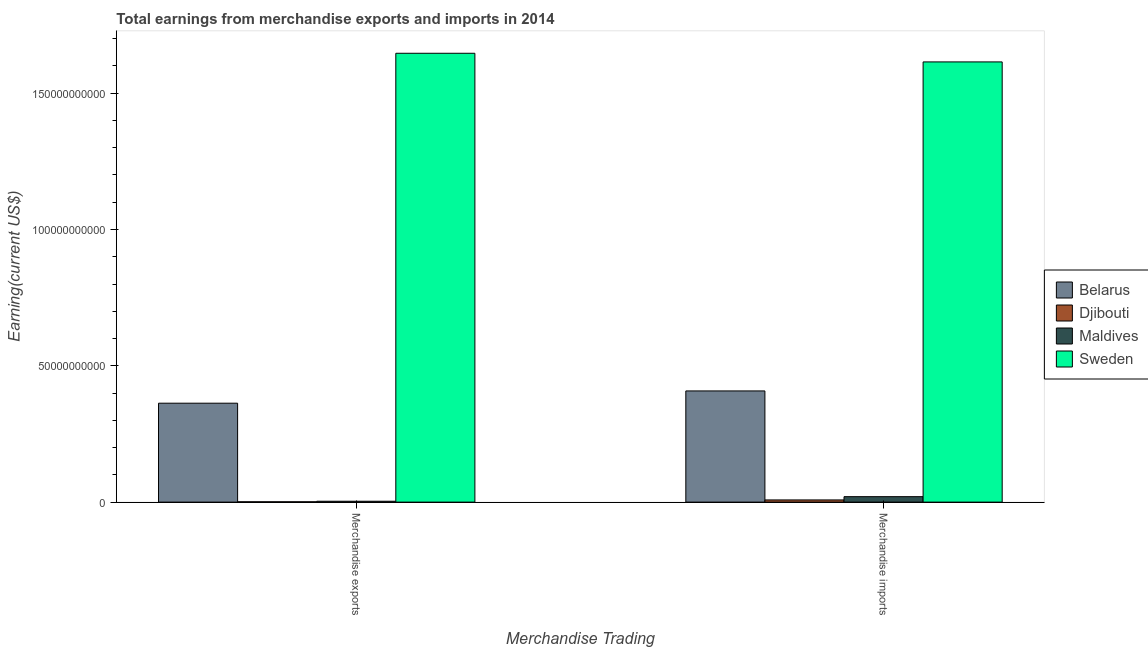Are the number of bars per tick equal to the number of legend labels?
Your response must be concise. Yes. How many bars are there on the 2nd tick from the right?
Offer a very short reply. 4. What is the earnings from merchandise exports in Maldives?
Provide a succinct answer. 3.26e+08. Across all countries, what is the maximum earnings from merchandise imports?
Give a very brief answer. 1.61e+11. Across all countries, what is the minimum earnings from merchandise exports?
Your response must be concise. 1.24e+08. In which country was the earnings from merchandise imports maximum?
Your answer should be very brief. Sweden. In which country was the earnings from merchandise imports minimum?
Ensure brevity in your answer.  Djibouti. What is the total earnings from merchandise imports in the graph?
Make the answer very short. 2.05e+11. What is the difference between the earnings from merchandise exports in Djibouti and that in Sweden?
Offer a terse response. -1.65e+11. What is the difference between the earnings from merchandise exports in Maldives and the earnings from merchandise imports in Djibouti?
Your response must be concise. -4.80e+08. What is the average earnings from merchandise imports per country?
Offer a terse response. 5.13e+1. What is the difference between the earnings from merchandise imports and earnings from merchandise exports in Belarus?
Your response must be concise. 4.50e+09. In how many countries, is the earnings from merchandise exports greater than 90000000000 US$?
Give a very brief answer. 1. What is the ratio of the earnings from merchandise exports in Djibouti to that in Belarus?
Your answer should be very brief. 0. What does the 1st bar from the left in Merchandise imports represents?
Your answer should be compact. Belarus. What does the 3rd bar from the right in Merchandise imports represents?
Your response must be concise. Djibouti. How many bars are there?
Provide a succinct answer. 8. What is the difference between two consecutive major ticks on the Y-axis?
Provide a short and direct response. 5.00e+1. Are the values on the major ticks of Y-axis written in scientific E-notation?
Ensure brevity in your answer.  No. How are the legend labels stacked?
Keep it short and to the point. Vertical. What is the title of the graph?
Ensure brevity in your answer.  Total earnings from merchandise exports and imports in 2014. Does "Angola" appear as one of the legend labels in the graph?
Your answer should be compact. No. What is the label or title of the X-axis?
Provide a short and direct response. Merchandise Trading. What is the label or title of the Y-axis?
Your response must be concise. Earning(current US$). What is the Earning(current US$) in Belarus in Merchandise exports?
Your response must be concise. 3.63e+1. What is the Earning(current US$) of Djibouti in Merchandise exports?
Your response must be concise. 1.24e+08. What is the Earning(current US$) in Maldives in Merchandise exports?
Make the answer very short. 3.26e+08. What is the Earning(current US$) in Sweden in Merchandise exports?
Offer a terse response. 1.65e+11. What is the Earning(current US$) of Belarus in Merchandise imports?
Offer a terse response. 4.08e+1. What is the Earning(current US$) in Djibouti in Merchandise imports?
Your answer should be compact. 8.06e+08. What is the Earning(current US$) of Maldives in Merchandise imports?
Your answer should be compact. 2.00e+09. What is the Earning(current US$) in Sweden in Merchandise imports?
Make the answer very short. 1.61e+11. Across all Merchandise Trading, what is the maximum Earning(current US$) in Belarus?
Give a very brief answer. 4.08e+1. Across all Merchandise Trading, what is the maximum Earning(current US$) of Djibouti?
Your response must be concise. 8.06e+08. Across all Merchandise Trading, what is the maximum Earning(current US$) in Maldives?
Your answer should be very brief. 2.00e+09. Across all Merchandise Trading, what is the maximum Earning(current US$) of Sweden?
Your response must be concise. 1.65e+11. Across all Merchandise Trading, what is the minimum Earning(current US$) of Belarus?
Make the answer very short. 3.63e+1. Across all Merchandise Trading, what is the minimum Earning(current US$) in Djibouti?
Make the answer very short. 1.24e+08. Across all Merchandise Trading, what is the minimum Earning(current US$) of Maldives?
Offer a terse response. 3.26e+08. Across all Merchandise Trading, what is the minimum Earning(current US$) of Sweden?
Your response must be concise. 1.61e+11. What is the total Earning(current US$) in Belarus in the graph?
Make the answer very short. 7.71e+1. What is the total Earning(current US$) of Djibouti in the graph?
Make the answer very short. 9.30e+08. What is the total Earning(current US$) of Maldives in the graph?
Keep it short and to the point. 2.33e+09. What is the total Earning(current US$) of Sweden in the graph?
Offer a very short reply. 3.26e+11. What is the difference between the Earning(current US$) in Belarus in Merchandise exports and that in Merchandise imports?
Offer a very short reply. -4.50e+09. What is the difference between the Earning(current US$) in Djibouti in Merchandise exports and that in Merchandise imports?
Offer a terse response. -6.82e+08. What is the difference between the Earning(current US$) of Maldives in Merchandise exports and that in Merchandise imports?
Offer a terse response. -1.68e+09. What is the difference between the Earning(current US$) of Sweden in Merchandise exports and that in Merchandise imports?
Ensure brevity in your answer.  3.17e+09. What is the difference between the Earning(current US$) in Belarus in Merchandise exports and the Earning(current US$) in Djibouti in Merchandise imports?
Keep it short and to the point. 3.55e+1. What is the difference between the Earning(current US$) of Belarus in Merchandise exports and the Earning(current US$) of Maldives in Merchandise imports?
Offer a terse response. 3.43e+1. What is the difference between the Earning(current US$) of Belarus in Merchandise exports and the Earning(current US$) of Sweden in Merchandise imports?
Offer a very short reply. -1.25e+11. What is the difference between the Earning(current US$) in Djibouti in Merchandise exports and the Earning(current US$) in Maldives in Merchandise imports?
Make the answer very short. -1.88e+09. What is the difference between the Earning(current US$) of Djibouti in Merchandise exports and the Earning(current US$) of Sweden in Merchandise imports?
Keep it short and to the point. -1.61e+11. What is the difference between the Earning(current US$) in Maldives in Merchandise exports and the Earning(current US$) in Sweden in Merchandise imports?
Your response must be concise. -1.61e+11. What is the average Earning(current US$) of Belarus per Merchandise Trading?
Keep it short and to the point. 3.85e+1. What is the average Earning(current US$) of Djibouti per Merchandise Trading?
Ensure brevity in your answer.  4.65e+08. What is the average Earning(current US$) of Maldives per Merchandise Trading?
Offer a very short reply. 1.17e+09. What is the average Earning(current US$) in Sweden per Merchandise Trading?
Your answer should be compact. 1.63e+11. What is the difference between the Earning(current US$) of Belarus and Earning(current US$) of Djibouti in Merchandise exports?
Your response must be concise. 3.62e+1. What is the difference between the Earning(current US$) in Belarus and Earning(current US$) in Maldives in Merchandise exports?
Your answer should be very brief. 3.60e+1. What is the difference between the Earning(current US$) of Belarus and Earning(current US$) of Sweden in Merchandise exports?
Your response must be concise. -1.28e+11. What is the difference between the Earning(current US$) in Djibouti and Earning(current US$) in Maldives in Merchandise exports?
Make the answer very short. -2.01e+08. What is the difference between the Earning(current US$) in Djibouti and Earning(current US$) in Sweden in Merchandise exports?
Make the answer very short. -1.65e+11. What is the difference between the Earning(current US$) in Maldives and Earning(current US$) in Sweden in Merchandise exports?
Offer a terse response. -1.64e+11. What is the difference between the Earning(current US$) of Belarus and Earning(current US$) of Djibouti in Merchandise imports?
Give a very brief answer. 4.00e+1. What is the difference between the Earning(current US$) in Belarus and Earning(current US$) in Maldives in Merchandise imports?
Your answer should be very brief. 3.88e+1. What is the difference between the Earning(current US$) in Belarus and Earning(current US$) in Sweden in Merchandise imports?
Your answer should be compact. -1.21e+11. What is the difference between the Earning(current US$) in Djibouti and Earning(current US$) in Maldives in Merchandise imports?
Provide a short and direct response. -1.20e+09. What is the difference between the Earning(current US$) of Djibouti and Earning(current US$) of Sweden in Merchandise imports?
Keep it short and to the point. -1.61e+11. What is the difference between the Earning(current US$) of Maldives and Earning(current US$) of Sweden in Merchandise imports?
Make the answer very short. -1.59e+11. What is the ratio of the Earning(current US$) of Belarus in Merchandise exports to that in Merchandise imports?
Your answer should be very brief. 0.89. What is the ratio of the Earning(current US$) of Djibouti in Merchandise exports to that in Merchandise imports?
Your answer should be very brief. 0.15. What is the ratio of the Earning(current US$) in Maldives in Merchandise exports to that in Merchandise imports?
Offer a very short reply. 0.16. What is the ratio of the Earning(current US$) in Sweden in Merchandise exports to that in Merchandise imports?
Make the answer very short. 1.02. What is the difference between the highest and the second highest Earning(current US$) of Belarus?
Provide a short and direct response. 4.50e+09. What is the difference between the highest and the second highest Earning(current US$) in Djibouti?
Your answer should be very brief. 6.82e+08. What is the difference between the highest and the second highest Earning(current US$) of Maldives?
Offer a terse response. 1.68e+09. What is the difference between the highest and the second highest Earning(current US$) in Sweden?
Offer a very short reply. 3.17e+09. What is the difference between the highest and the lowest Earning(current US$) of Belarus?
Your response must be concise. 4.50e+09. What is the difference between the highest and the lowest Earning(current US$) in Djibouti?
Make the answer very short. 6.82e+08. What is the difference between the highest and the lowest Earning(current US$) in Maldives?
Your response must be concise. 1.68e+09. What is the difference between the highest and the lowest Earning(current US$) in Sweden?
Make the answer very short. 3.17e+09. 